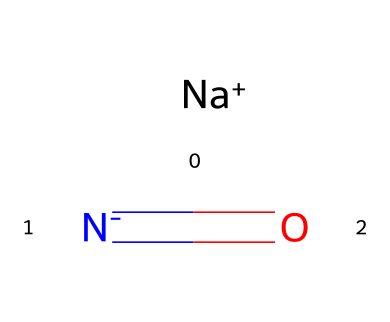What is the ionic form of the sodium in this structure? The structure indicates that sodium is present in its ionic form as [Na+], which is represented by the '+' sign denoting a positive charge.
Answer: sodium ion How many nitrogen atoms are present in this structure? Upon examining the structure, there is one nitrogen atom in the ion [N-], signifying that it is a nitrite ion (NO2-) which contains one nitrogen.
Answer: one What type of bond is present between sodium and the nitrite ion? The bond between sodium and the nitrite ion is ionic; sodium carries a positive charge while the nitrite ion carries a negative charge, leading to an electrostatic attraction.
Answer: ionic bond What is the oxidation state of nitrogen in this molecule? In the nitrite ion, nitrogen has an oxidation state of +3 because it is bonded to two oxygen atoms, which typically have an oxidation state of -2 each. The total charge of the ion is -1, which balances the oxidation states accordingly.
Answer: +3 What role does sodium nitrite play in fertilizer preservation? Sodium nitrite acts as a preservative by inhibiting microbial growth and preventing deterioration of the fertilizer, thereby maintaining its efficiency and effectiveness.
Answer: preservative 